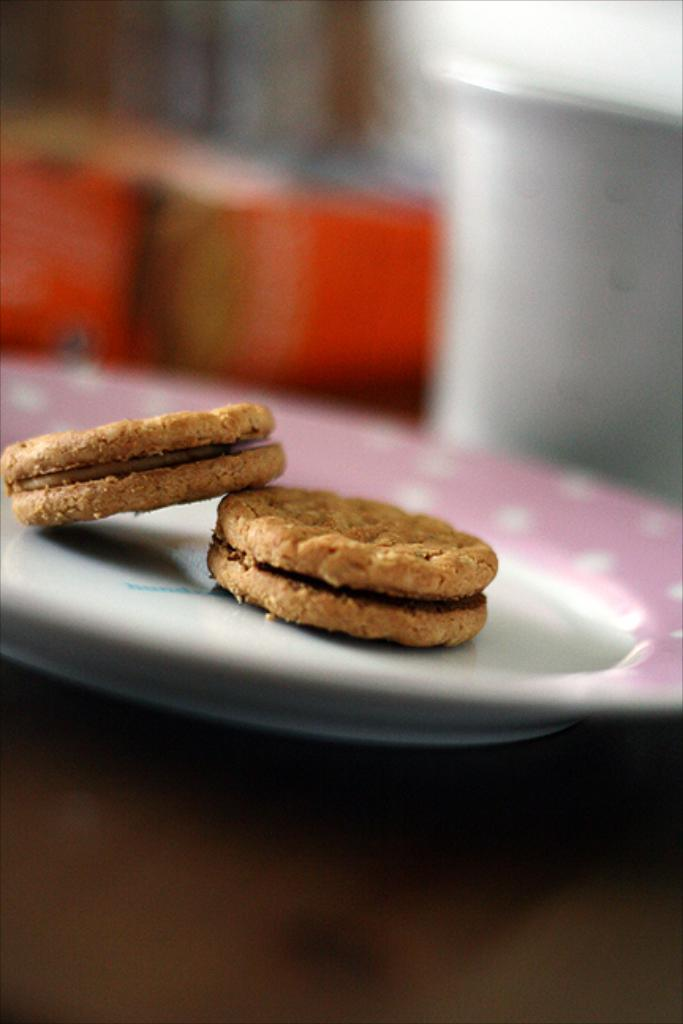What is the main object in the center of the image? There is a table in the center of the image. What food items can be seen on the table? There are cookies on a plate on the table. What else is on the table besides the cookies? There is a glass and other objects on the table. Can you describe the background of the image? The background of the image is blurry. What type of cap is the person wearing in the image? There is no person wearing a cap in the image; it only features a table with cookies, a glass, and other objects. What type of education is being discussed in the image? There is no discussion of education in the image; it only features a table with cookies, a glass, and other objects. 